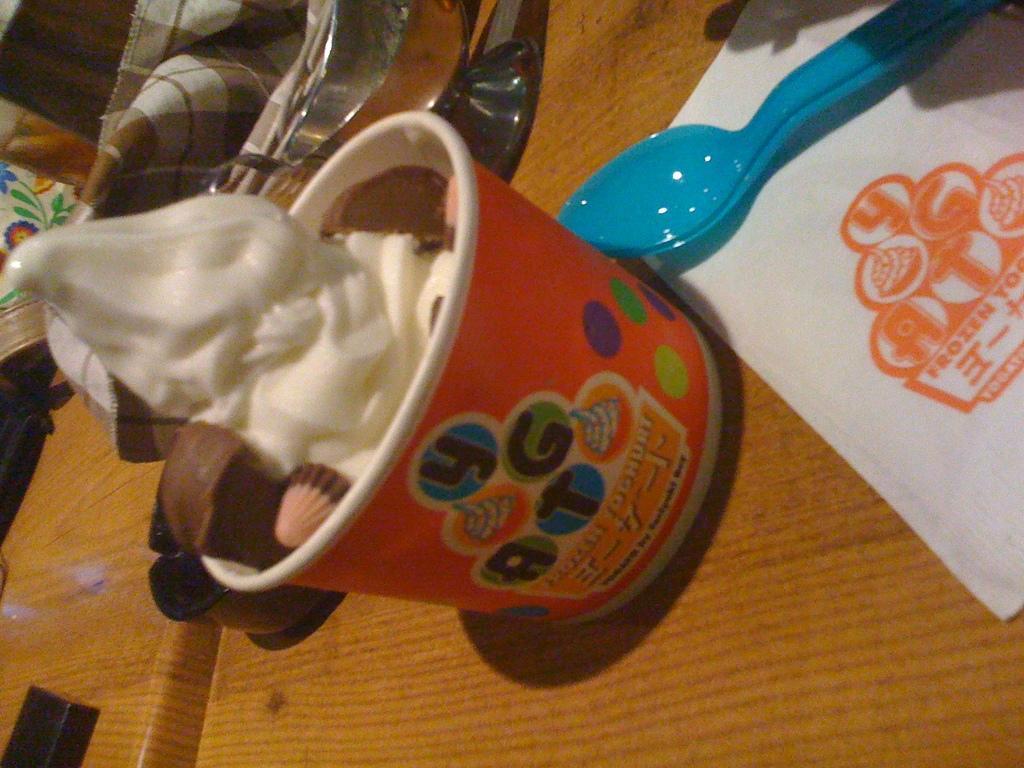Please provide a concise description of this image. This image consists of a table, tissues, spoon, a bowl and ice cream in it. There is a cloth at the top. 